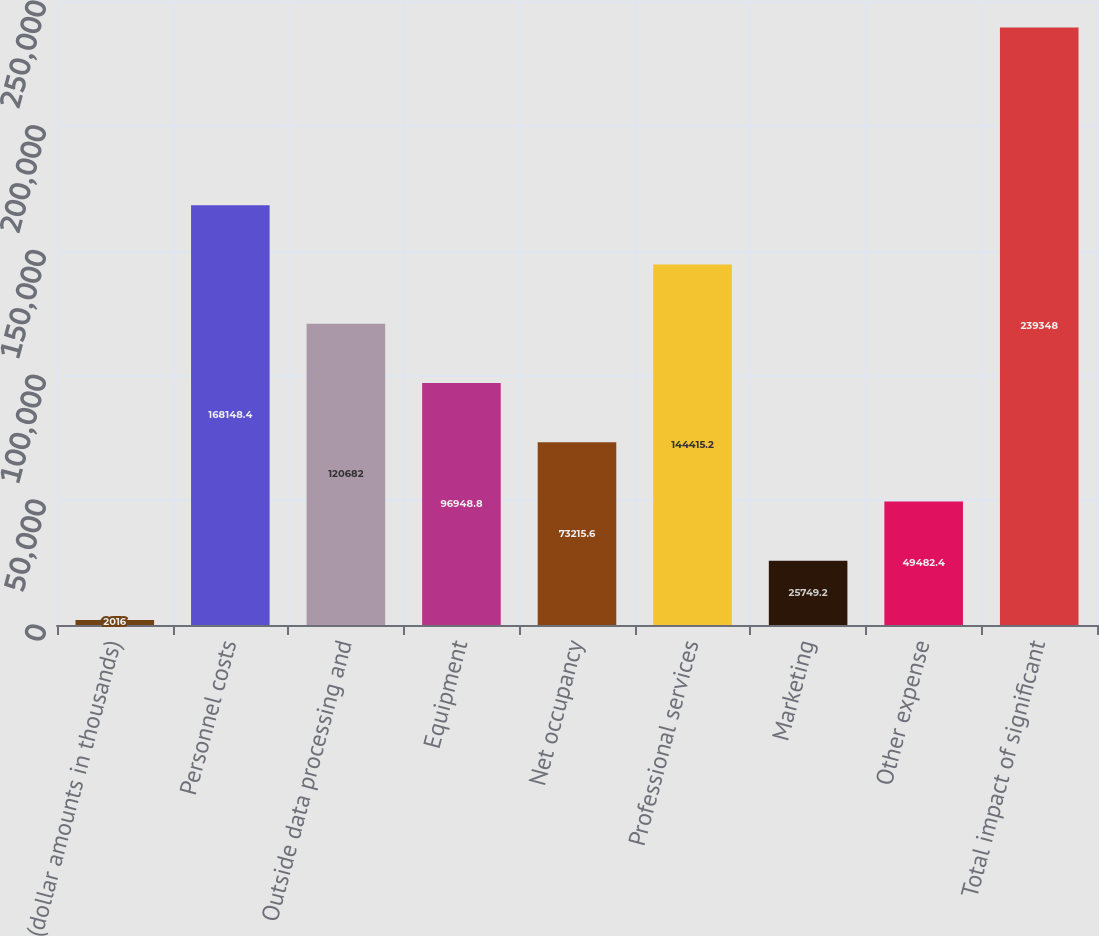Convert chart. <chart><loc_0><loc_0><loc_500><loc_500><bar_chart><fcel>(dollar amounts in thousands)<fcel>Personnel costs<fcel>Outside data processing and<fcel>Equipment<fcel>Net occupancy<fcel>Professional services<fcel>Marketing<fcel>Other expense<fcel>Total impact of significant<nl><fcel>2016<fcel>168148<fcel>120682<fcel>96948.8<fcel>73215.6<fcel>144415<fcel>25749.2<fcel>49482.4<fcel>239348<nl></chart> 